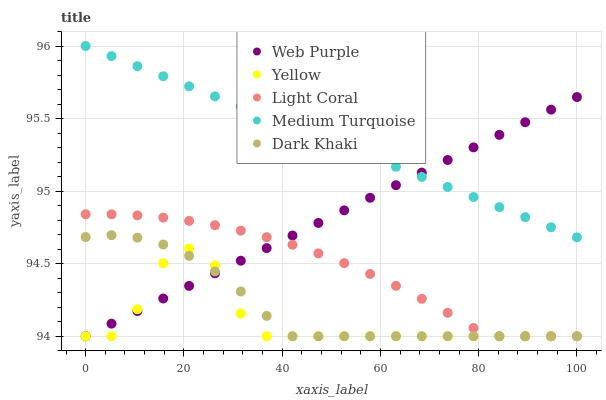Does Yellow have the minimum area under the curve?
Answer yes or no. Yes. Does Medium Turquoise have the maximum area under the curve?
Answer yes or no. Yes. Does Dark Khaki have the minimum area under the curve?
Answer yes or no. No. Does Dark Khaki have the maximum area under the curve?
Answer yes or no. No. Is Web Purple the smoothest?
Answer yes or no. Yes. Is Yellow the roughest?
Answer yes or no. Yes. Is Dark Khaki the smoothest?
Answer yes or no. No. Is Dark Khaki the roughest?
Answer yes or no. No. Does Light Coral have the lowest value?
Answer yes or no. Yes. Does Medium Turquoise have the lowest value?
Answer yes or no. No. Does Medium Turquoise have the highest value?
Answer yes or no. Yes. Does Dark Khaki have the highest value?
Answer yes or no. No. Is Yellow less than Medium Turquoise?
Answer yes or no. Yes. Is Medium Turquoise greater than Yellow?
Answer yes or no. Yes. Does Light Coral intersect Dark Khaki?
Answer yes or no. Yes. Is Light Coral less than Dark Khaki?
Answer yes or no. No. Is Light Coral greater than Dark Khaki?
Answer yes or no. No. Does Yellow intersect Medium Turquoise?
Answer yes or no. No. 